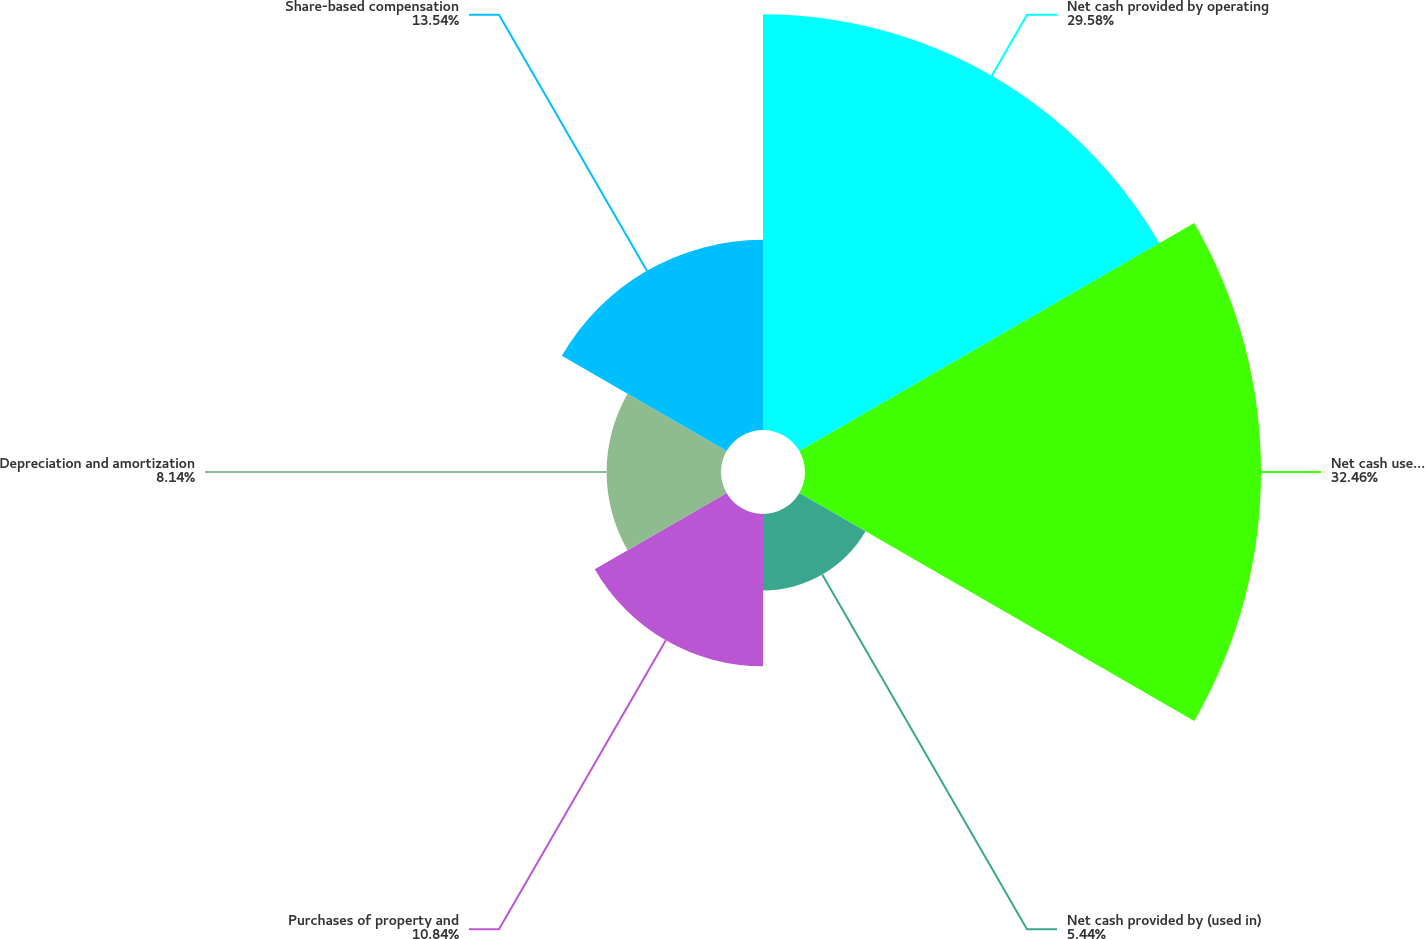<chart> <loc_0><loc_0><loc_500><loc_500><pie_chart><fcel>Net cash provided by operating<fcel>Net cash used in investing<fcel>Net cash provided by (used in)<fcel>Purchases of property and<fcel>Depreciation and amortization<fcel>Share-based compensation<nl><fcel>29.58%<fcel>32.45%<fcel>5.44%<fcel>10.84%<fcel>8.14%<fcel>13.54%<nl></chart> 